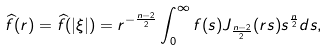<formula> <loc_0><loc_0><loc_500><loc_500>\widehat { f } ( r ) = \widehat { f } ( | \xi | ) = r ^ { - \frac { n - 2 } 2 } \int _ { 0 } ^ { \infty } f ( s ) J _ { \frac { n - 2 } 2 } ( r s ) s ^ { \frac { n } { 2 } } d s ,</formula> 